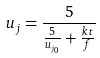<formula> <loc_0><loc_0><loc_500><loc_500>u _ { j } = \frac { 5 } { \frac { 5 } { u _ { j _ { 0 } } } + \frac { k t } { f } }</formula> 